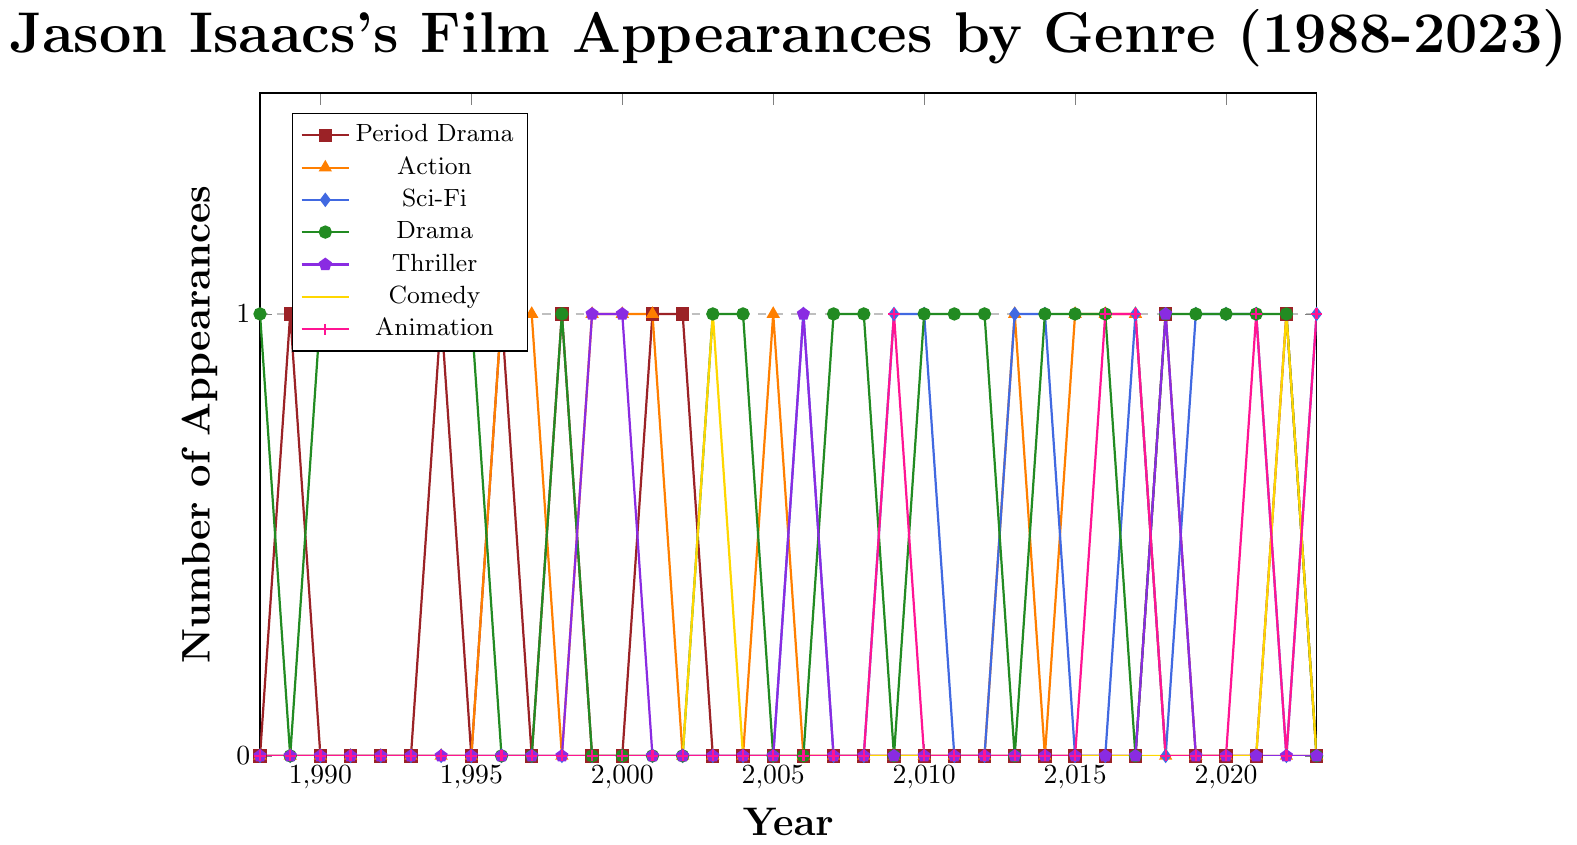What was the first year where Jason Isaacs appeared in a period drama? Scan the plot for the line representing period drama and find the first data point above 0, which is in 1989.
Answer: 1989 In which year did Jason Isaacs have his first appearance in an animated film? Look for the first year where the line for animation (marked with plus signs) rises above 0, which happens in 2009.
Answer: 2009 Between 2000 and 2010, how many different genres did Jason Isaacs appear in? Check the plot from 2000 to 2010 and identify the lines that rise above 0. Period Drama, Action, Sci-Fi, Drama, and Thriller are the genres.
Answer: 5 Which genre did Jason Isaacs appear in most frequently between 1996 and 2005? Count occurrences by genre within these years. Drama has the highest count, appearing in 4 of these years.
Answer: Drama Did Jason Isaacs appear in more period dramas or thrillers throughout his career? Look at the lines for period drama and thriller across all years and count the number of data points above 0. Period Drama: 9 times; Thriller: 4 times.
Answer: Period Drama In which year did Jason Isaacs have an equal number of appearances in both action and sci-fi genres? Find the years where both action and sci-fi lines are at the same level. That happens in 2013.
Answer: 2013 During 2016 to 2018, did Jason Isaacs appear in more comedies or dramas? Count the number of appearances in comedy and drama. Comedy: 0; Drama: 3.
Answer: Drama What genre did Jason Isaacs appear in least frequently and what's the total count? Identify the genre with the least number of appearances by scanning height over years. Comedy and Thriller are tied with 3 total appearances each.
Answer: Comedy and Thriller, 3 Did Jason Isaacs have any film appearances in 1988? If yes, in which genre? Check if any of the lines rise above 0 in 1988. Only Drama has an appearance.
Answer: Yes, Drama Between 2015 and 2020, which genre saw a rise in the number of appearances for Jason Isaacs? Check the data points for each genre. Sci-Fi rose consistently from 2015 to 2020.
Answer: Sci-Fi 